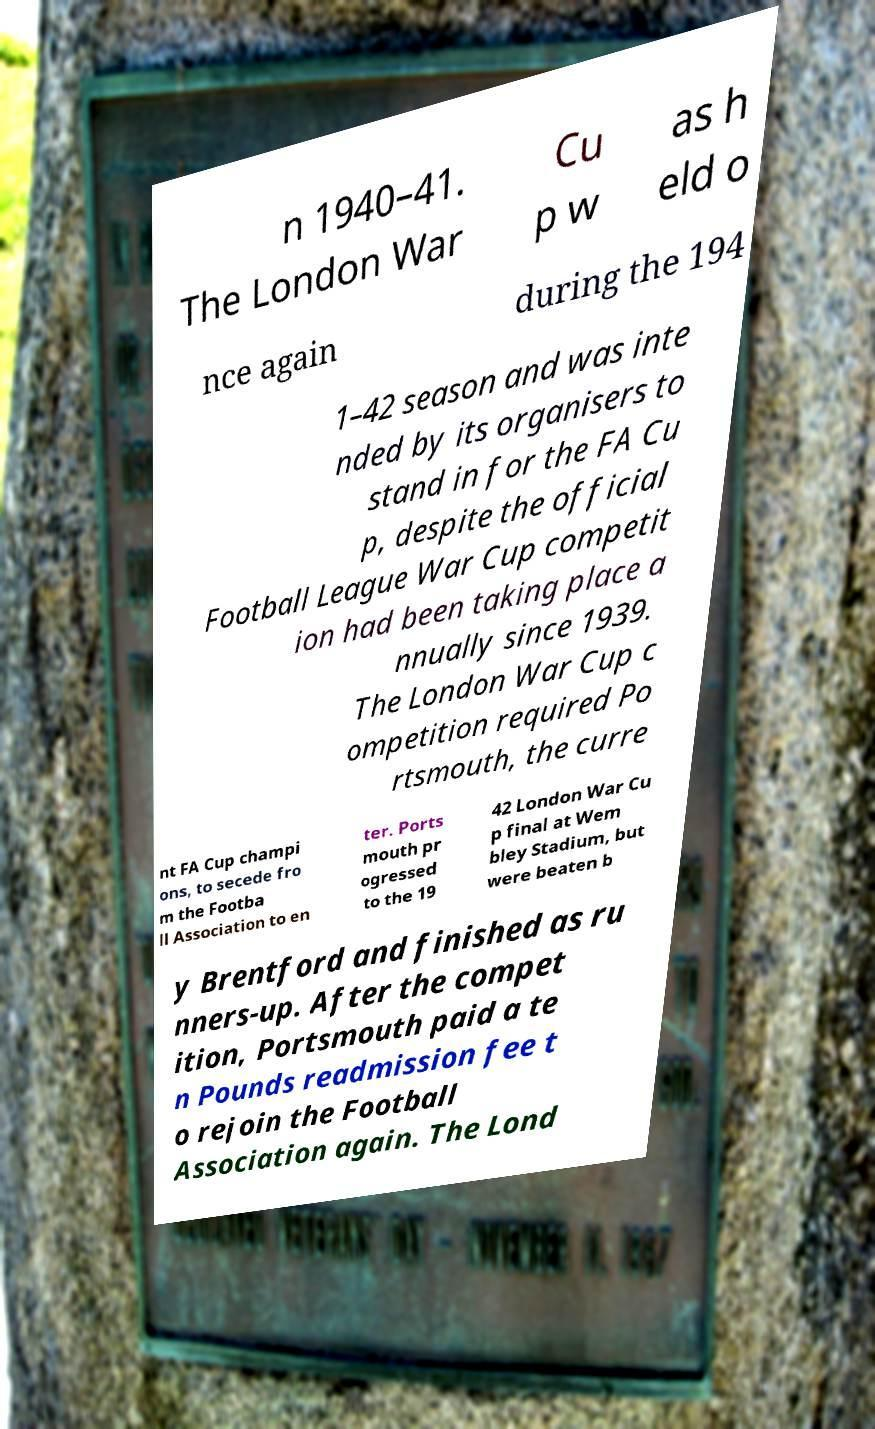Can you read and provide the text displayed in the image?This photo seems to have some interesting text. Can you extract and type it out for me? n 1940–41. The London War Cu p w as h eld o nce again during the 194 1–42 season and was inte nded by its organisers to stand in for the FA Cu p, despite the official Football League War Cup competit ion had been taking place a nnually since 1939. The London War Cup c ompetition required Po rtsmouth, the curre nt FA Cup champi ons, to secede fro m the Footba ll Association to en ter. Ports mouth pr ogressed to the 19 42 London War Cu p final at Wem bley Stadium, but were beaten b y Brentford and finished as ru nners-up. After the compet ition, Portsmouth paid a te n Pounds readmission fee t o rejoin the Football Association again. The Lond 